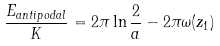Convert formula to latex. <formula><loc_0><loc_0><loc_500><loc_500>\frac { E _ { a n t i p o d a l } } { K } = 2 \pi \ln \frac { 2 } { a } - 2 \pi \omega ( z _ { 1 } )</formula> 